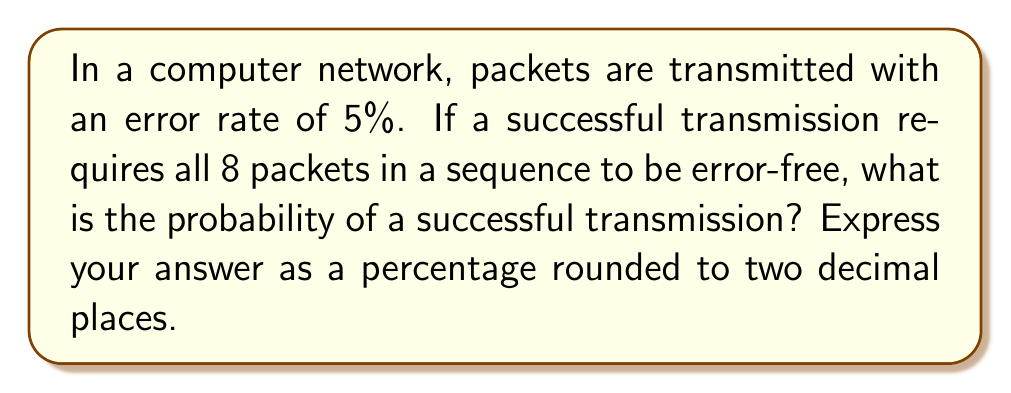Can you solve this math problem? Let's approach this step-by-step:

1) First, we need to calculate the probability of a single packet being transmitted successfully. If the error rate is 5%, then the success rate for a single packet is:

   $1 - 0.05 = 0.95$ or 95%

2) Now, we need all 8 packets to be transmitted successfully. This is a case of independent events, where the probability of all events occurring is the product of their individual probabilities.

3) The probability of all 8 packets being successful is:

   $$(0.95)^8$$

4) Let's calculate this:

   $$(0.95)^8 \approx 0.6634$$

5) To convert this to a percentage, we multiply by 100:

   $$0.6634 * 100 \approx 66.34\%$$

6) Rounding to two decimal places gives us 66.34%.

This problem demonstrates how small error rates can compound in complex systems, a concept crucial in computer networking and error correction algorithms.
Answer: 66.34% 